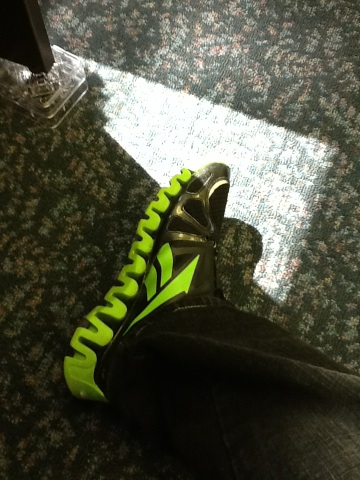Where do you think these shoes could be typically worn? These shoes, with their robust design and vivid green and black colors, seem perfect for outdoor activities, especially sports like trail running or hiking. Their sturdy build and vibrant colors also make them suitable for casual outings where one might want to make a fashion statement. 